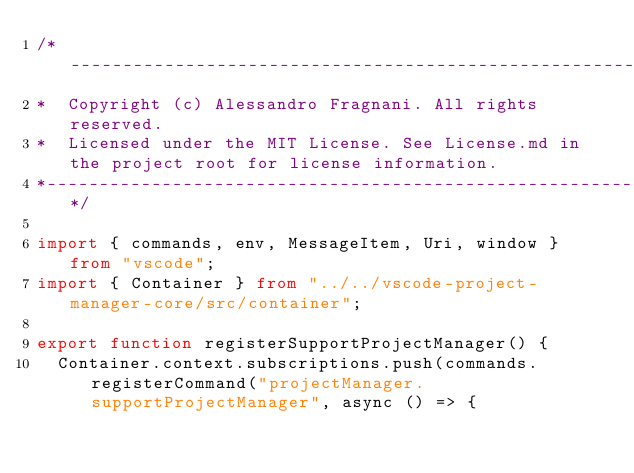Convert code to text. <code><loc_0><loc_0><loc_500><loc_500><_TypeScript_>/*---------------------------------------------------------------------------------------------
*  Copyright (c) Alessandro Fragnani. All rights reserved.
*  Licensed under the MIT License. See License.md in the project root for license information.
*--------------------------------------------------------------------------------------------*/

import { commands, env, MessageItem, Uri, window } from "vscode";
import { Container } from "../../vscode-project-manager-core/src/container";

export function registerSupportProjectManager() {
  Container.context.subscriptions.push(commands.registerCommand("projectManager.supportProjectManager", async () => {</code> 